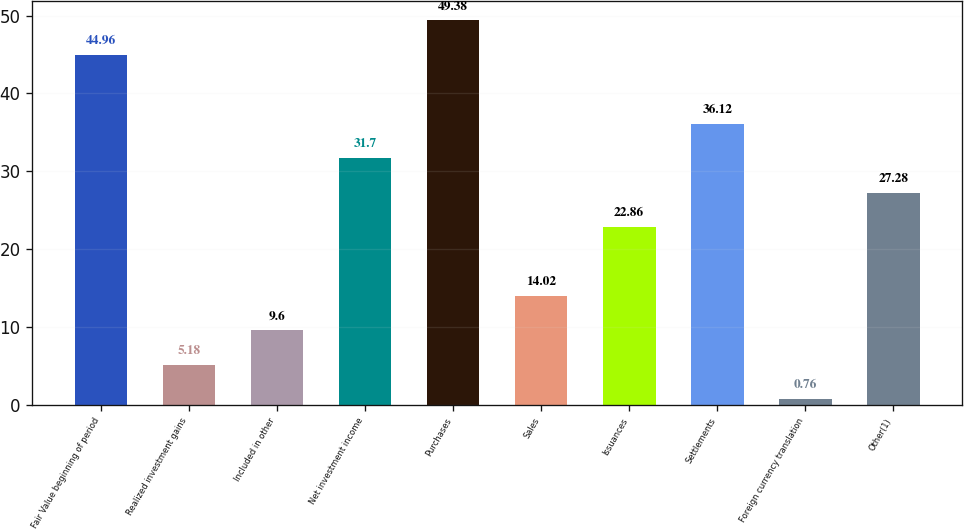Convert chart to OTSL. <chart><loc_0><loc_0><loc_500><loc_500><bar_chart><fcel>Fair Value beginning of period<fcel>Realized investment gains<fcel>Included in other<fcel>Net investment income<fcel>Purchases<fcel>Sales<fcel>Issuances<fcel>Settlements<fcel>Foreign currency translation<fcel>Other(1)<nl><fcel>44.96<fcel>5.18<fcel>9.6<fcel>31.7<fcel>49.38<fcel>14.02<fcel>22.86<fcel>36.12<fcel>0.76<fcel>27.28<nl></chart> 